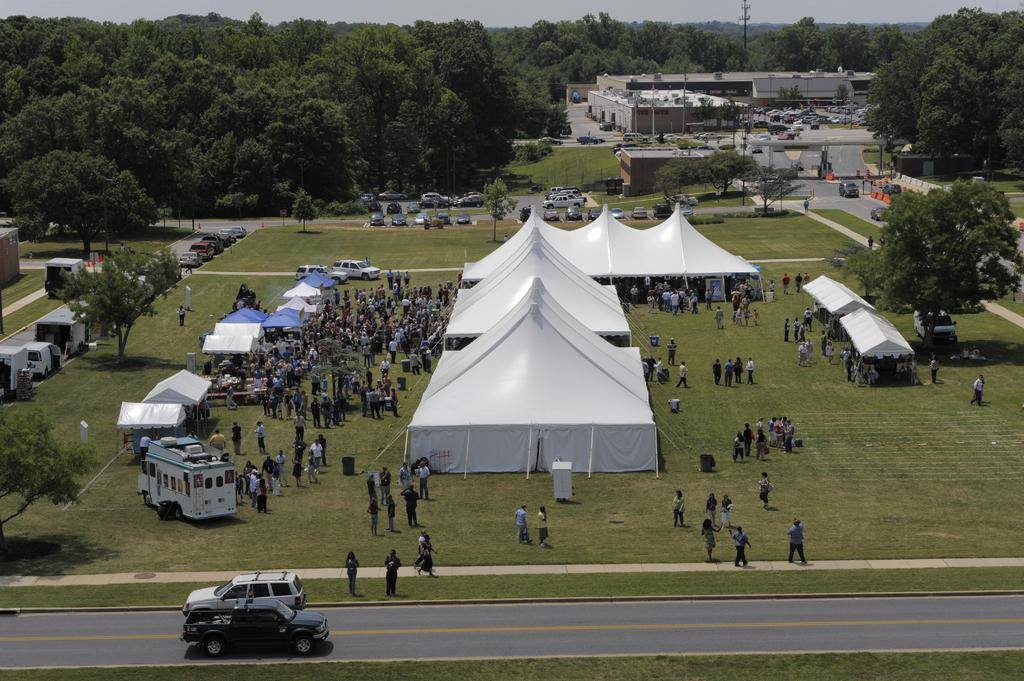What can be seen in the foreground of the image? In the foreground of the image, there are people and vehicles, and people are on the grassland. Can you describe the background of the image? In the background of the image, there are trees, vehicles, buildings, a pole, and the sky is visible. In which direction are the trees rolling in the image? There are no trees rolling in the image; trees are stationary and not depicted as moving. 